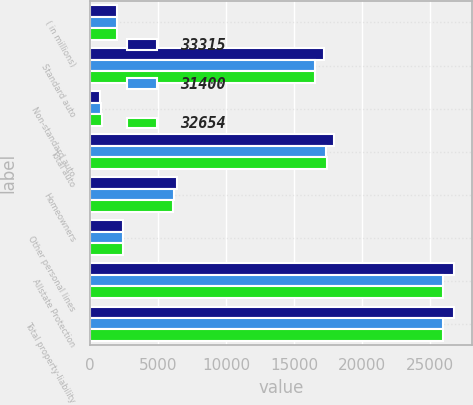Convert chart to OTSL. <chart><loc_0><loc_0><loc_500><loc_500><stacked_bar_chart><ecel><fcel>( in millions)<fcel>Standard auto<fcel>Non-standard auto<fcel>Total auto<fcel>Homeowners<fcel>Other personal lines<fcel>Allstate Protection<fcel>Total property-liability<nl><fcel>33315<fcel>2012<fcel>17213<fcel>715<fcel>17928<fcel>6359<fcel>2450<fcel>26737<fcel>26737<nl><fcel>31400<fcel>2011<fcel>16500<fcel>799<fcel>17299<fcel>6200<fcel>2443<fcel>25942<fcel>25942<nl><fcel>32654<fcel>2010<fcel>16530<fcel>905<fcel>17435<fcel>6078<fcel>2442<fcel>25955<fcel>25957<nl></chart> 